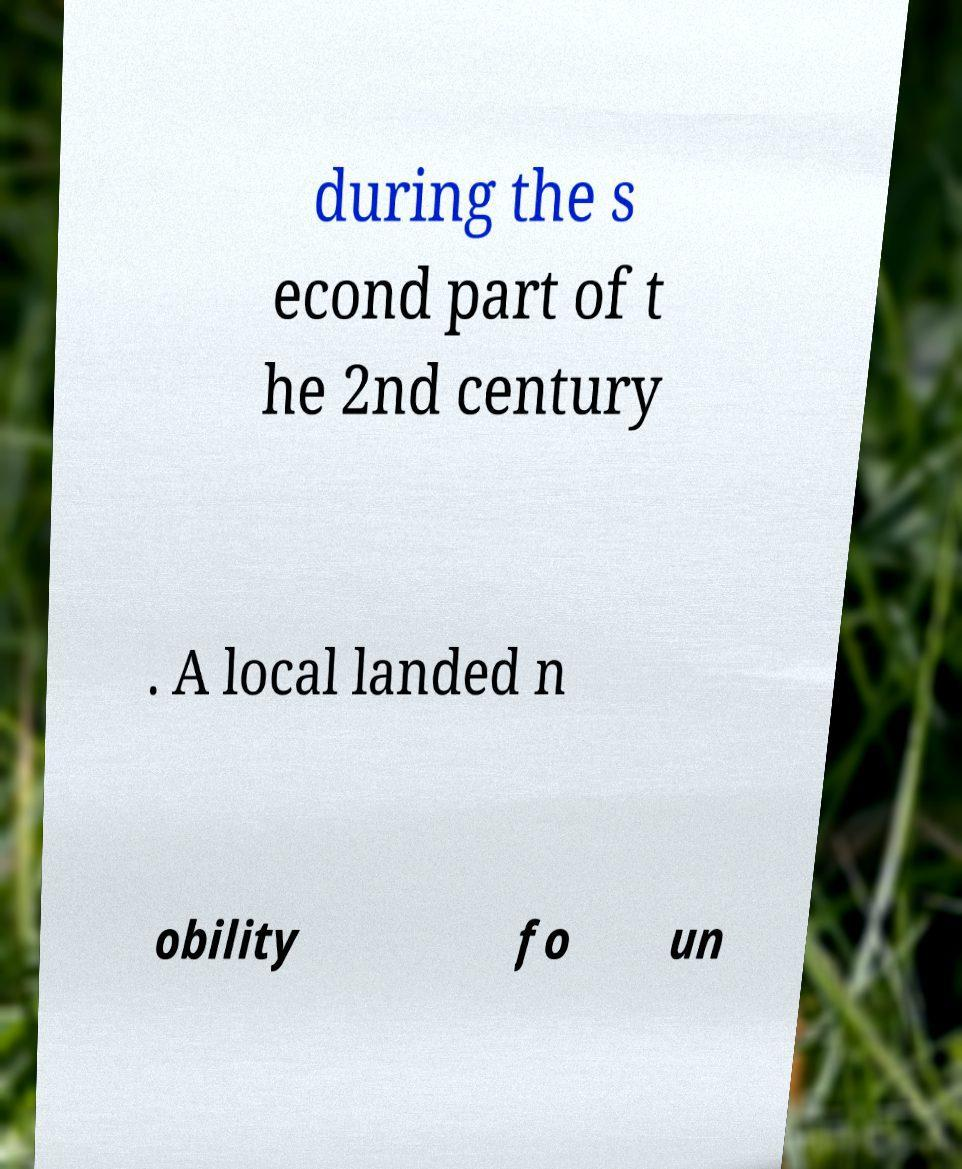There's text embedded in this image that I need extracted. Can you transcribe it verbatim? during the s econd part of t he 2nd century . A local landed n obility fo un 